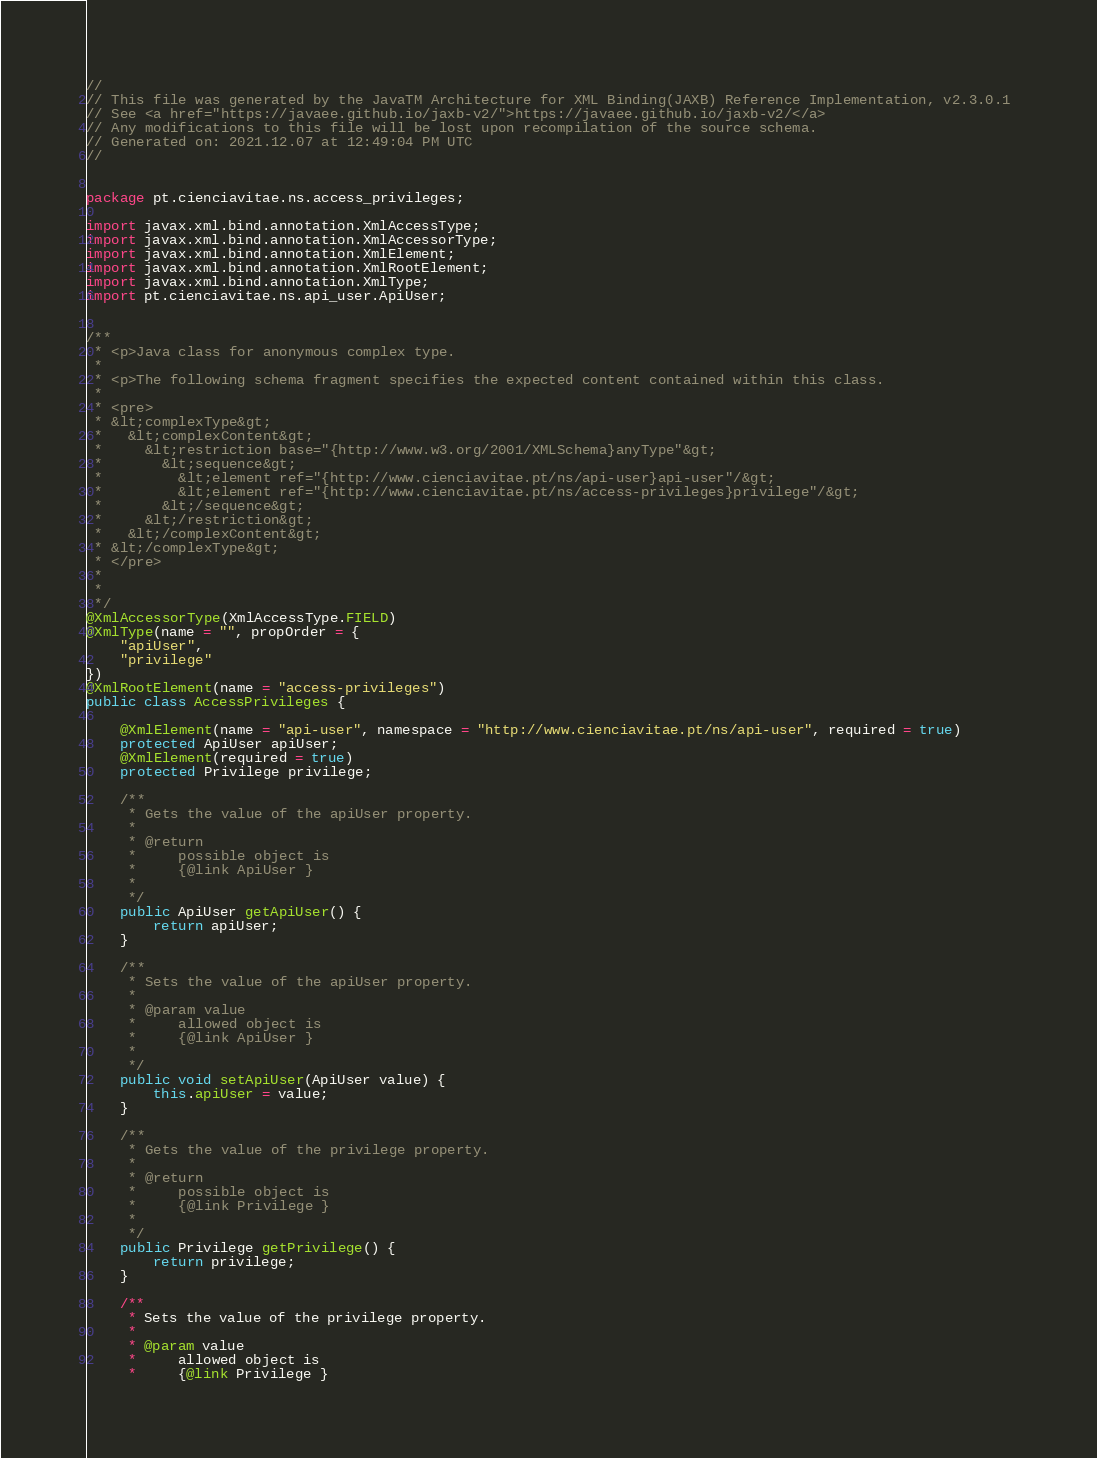<code> <loc_0><loc_0><loc_500><loc_500><_Java_>//
// This file was generated by the JavaTM Architecture for XML Binding(JAXB) Reference Implementation, v2.3.0.1 
// See <a href="https://javaee.github.io/jaxb-v2/">https://javaee.github.io/jaxb-v2/</a> 
// Any modifications to this file will be lost upon recompilation of the source schema. 
// Generated on: 2021.12.07 at 12:49:04 PM UTC 
//


package pt.cienciavitae.ns.access_privileges;

import javax.xml.bind.annotation.XmlAccessType;
import javax.xml.bind.annotation.XmlAccessorType;
import javax.xml.bind.annotation.XmlElement;
import javax.xml.bind.annotation.XmlRootElement;
import javax.xml.bind.annotation.XmlType;
import pt.cienciavitae.ns.api_user.ApiUser;


/**
 * <p>Java class for anonymous complex type.
 * 
 * <p>The following schema fragment specifies the expected content contained within this class.
 * 
 * <pre>
 * &lt;complexType&gt;
 *   &lt;complexContent&gt;
 *     &lt;restriction base="{http://www.w3.org/2001/XMLSchema}anyType"&gt;
 *       &lt;sequence&gt;
 *         &lt;element ref="{http://www.cienciavitae.pt/ns/api-user}api-user"/&gt;
 *         &lt;element ref="{http://www.cienciavitae.pt/ns/access-privileges}privilege"/&gt;
 *       &lt;/sequence&gt;
 *     &lt;/restriction&gt;
 *   &lt;/complexContent&gt;
 * &lt;/complexType&gt;
 * </pre>
 * 
 * 
 */
@XmlAccessorType(XmlAccessType.FIELD)
@XmlType(name = "", propOrder = {
    "apiUser",
    "privilege"
})
@XmlRootElement(name = "access-privileges")
public class AccessPrivileges {

    @XmlElement(name = "api-user", namespace = "http://www.cienciavitae.pt/ns/api-user", required = true)
    protected ApiUser apiUser;
    @XmlElement(required = true)
    protected Privilege privilege;

    /**
     * Gets the value of the apiUser property.
     * 
     * @return
     *     possible object is
     *     {@link ApiUser }
     *     
     */
    public ApiUser getApiUser() {
        return apiUser;
    }

    /**
     * Sets the value of the apiUser property.
     * 
     * @param value
     *     allowed object is
     *     {@link ApiUser }
     *     
     */
    public void setApiUser(ApiUser value) {
        this.apiUser = value;
    }

    /**
     * Gets the value of the privilege property.
     * 
     * @return
     *     possible object is
     *     {@link Privilege }
     *     
     */
    public Privilege getPrivilege() {
        return privilege;
    }

    /**
     * Sets the value of the privilege property.
     * 
     * @param value
     *     allowed object is
     *     {@link Privilege }</code> 